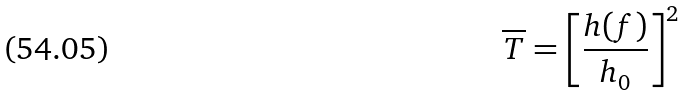Convert formula to latex. <formula><loc_0><loc_0><loc_500><loc_500>\overline { T } = \left [ \frac { h ( f ) } { h _ { 0 } } \right ] ^ { 2 }</formula> 